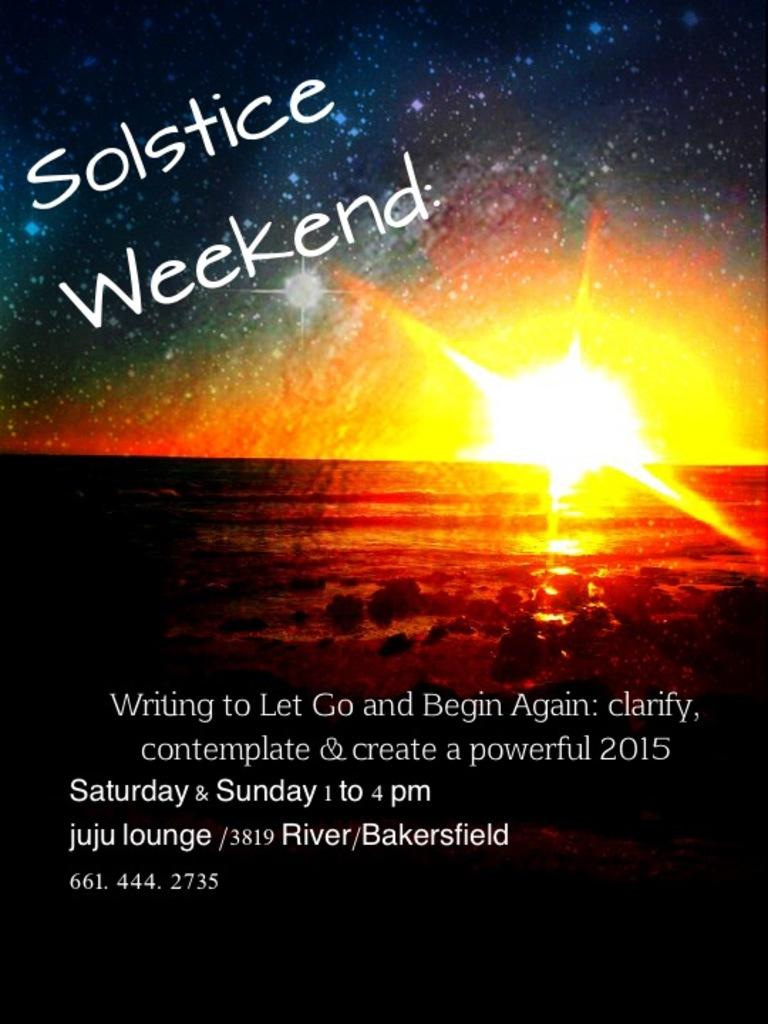Provide a one-sentence caption for the provided image. a poster of a sunset that says 'solstice weekend' on it. 